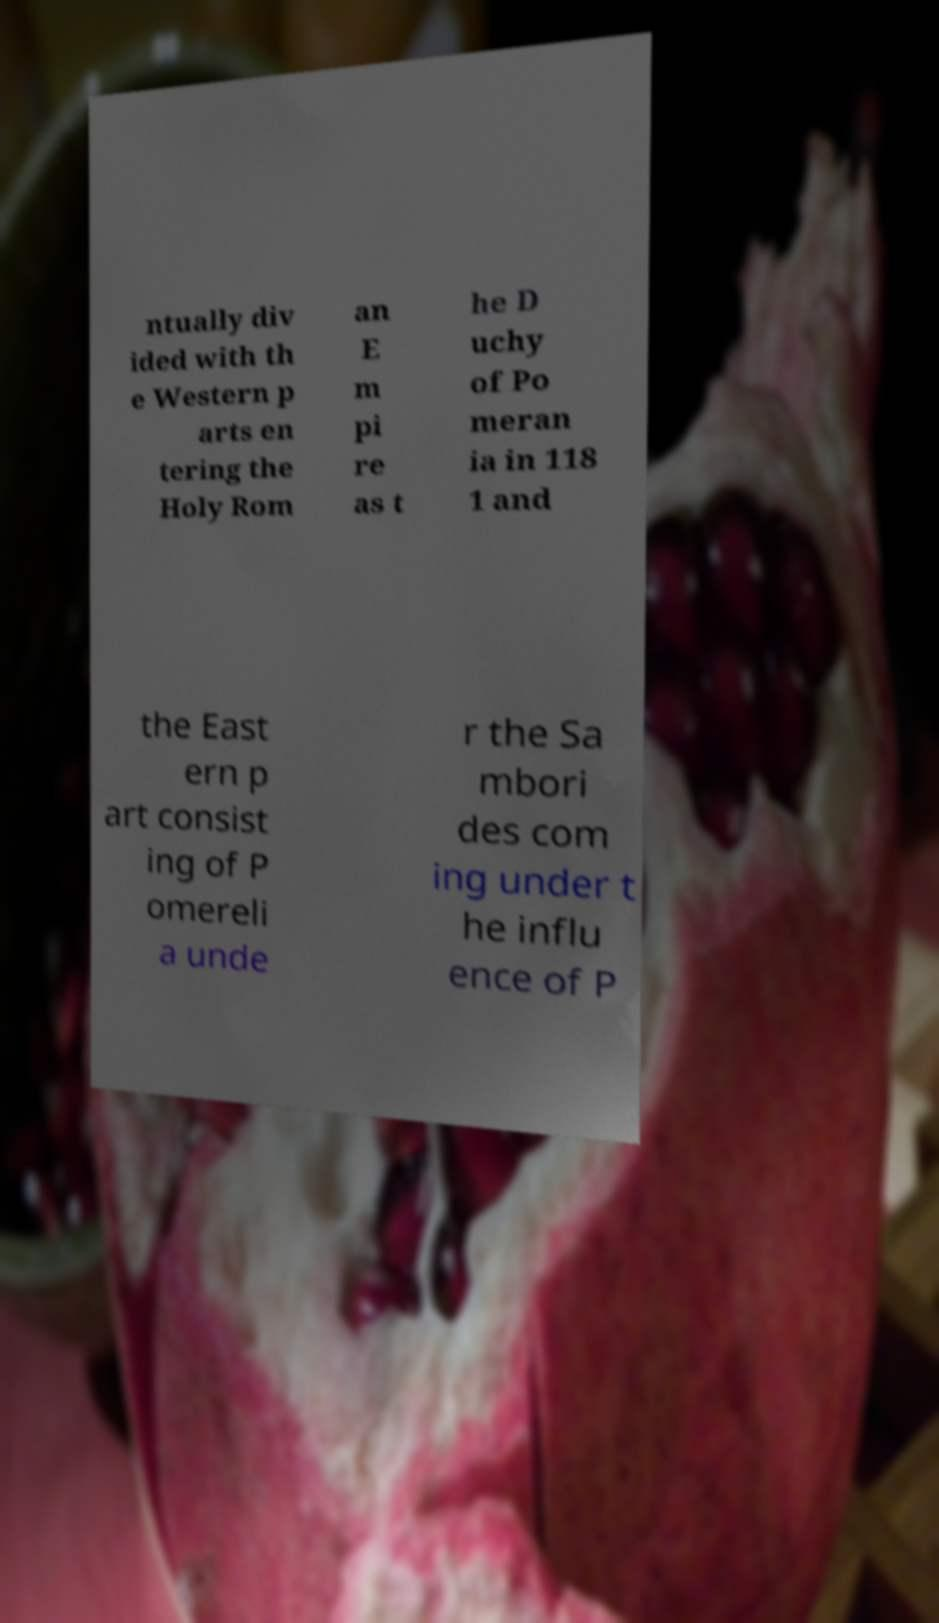Can you accurately transcribe the text from the provided image for me? ntually div ided with th e Western p arts en tering the Holy Rom an E m pi re as t he D uchy of Po meran ia in 118 1 and the East ern p art consist ing of P omereli a unde r the Sa mbori des com ing under t he influ ence of P 